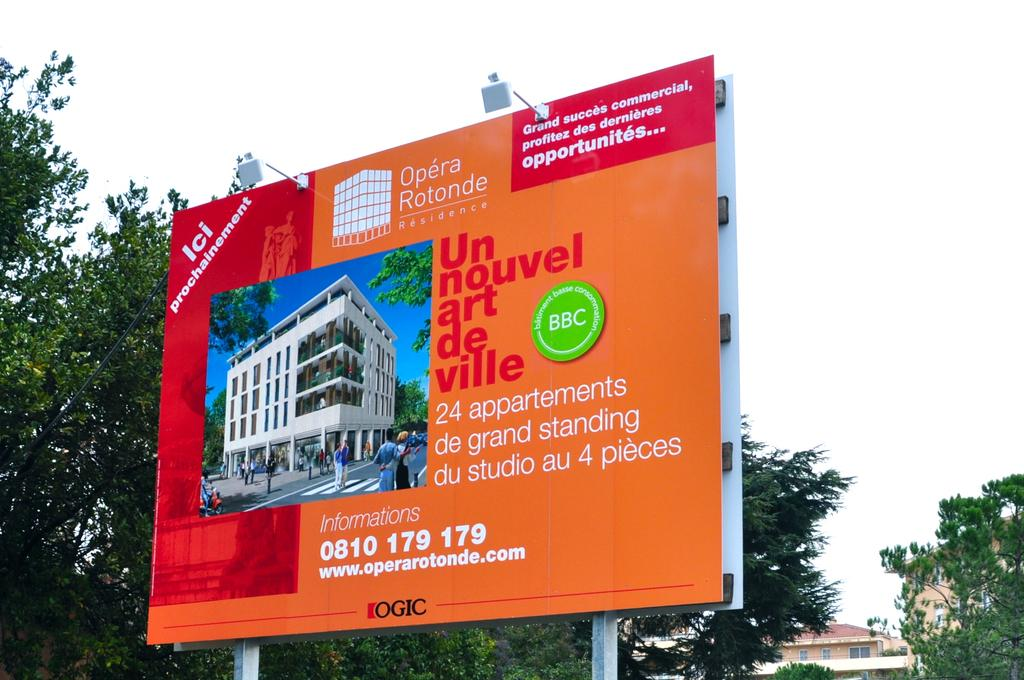What structures are present on the poles in the image? There are poles with hoardings and lights in the image. What can be seen behind the hoardings? Trees and buildings are visible behind the hoardings. What is visible in the sky in the image? The sky is visible in the image. How many ladybugs are crawling on the hoardings in the image? There are no ladybugs present on the hoardings in the image. What is the value of the quarter visible on the pole in the image? There is no quarter visible on the pole in the image. 